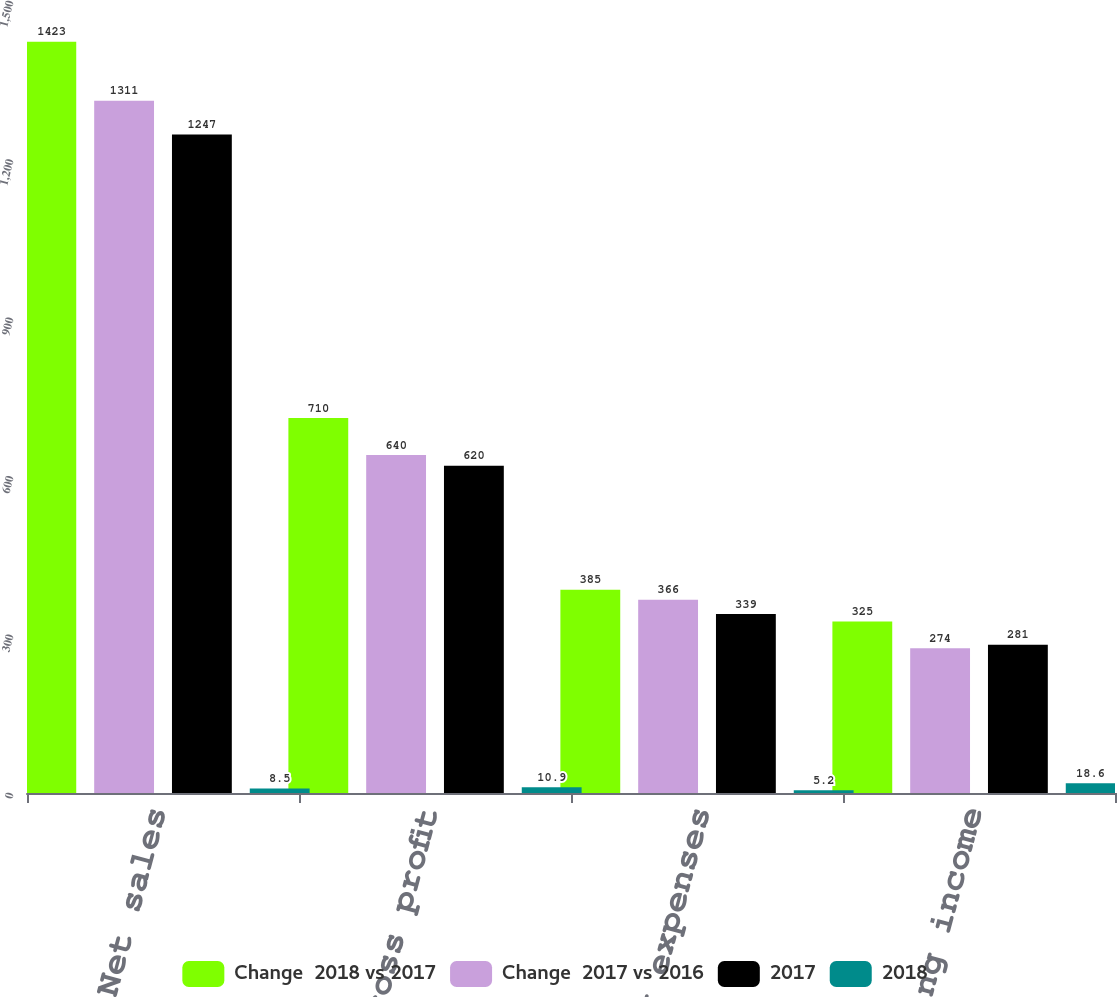Convert chart to OTSL. <chart><loc_0><loc_0><loc_500><loc_500><stacked_bar_chart><ecel><fcel>Net sales<fcel>Gross profit<fcel>Operating expenses<fcel>Operating income<nl><fcel>Change  2018 vs 2017<fcel>1423<fcel>710<fcel>385<fcel>325<nl><fcel>Change  2017 vs 2016<fcel>1311<fcel>640<fcel>366<fcel>274<nl><fcel>2017<fcel>1247<fcel>620<fcel>339<fcel>281<nl><fcel>2018<fcel>8.5<fcel>10.9<fcel>5.2<fcel>18.6<nl></chart> 